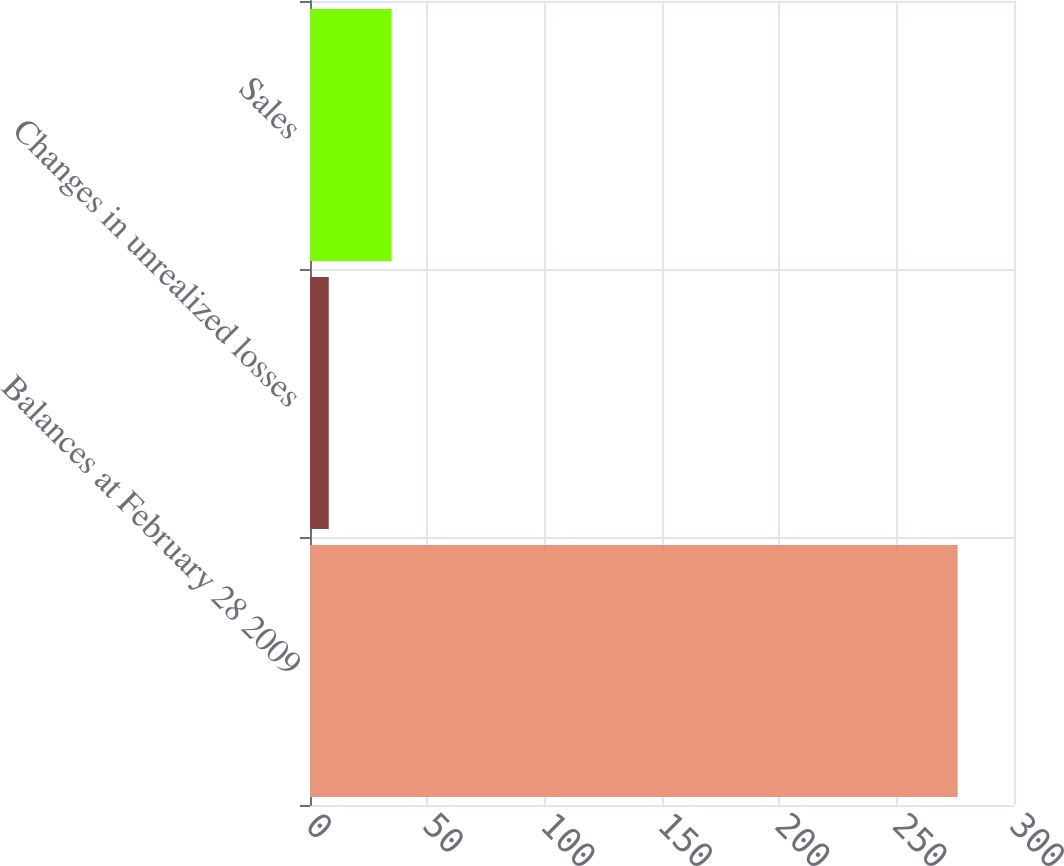Convert chart to OTSL. <chart><loc_0><loc_0><loc_500><loc_500><bar_chart><fcel>Balances at February 28 2009<fcel>Changes in unrealized losses<fcel>Sales<nl><fcel>276<fcel>8<fcel>34.8<nl></chart> 